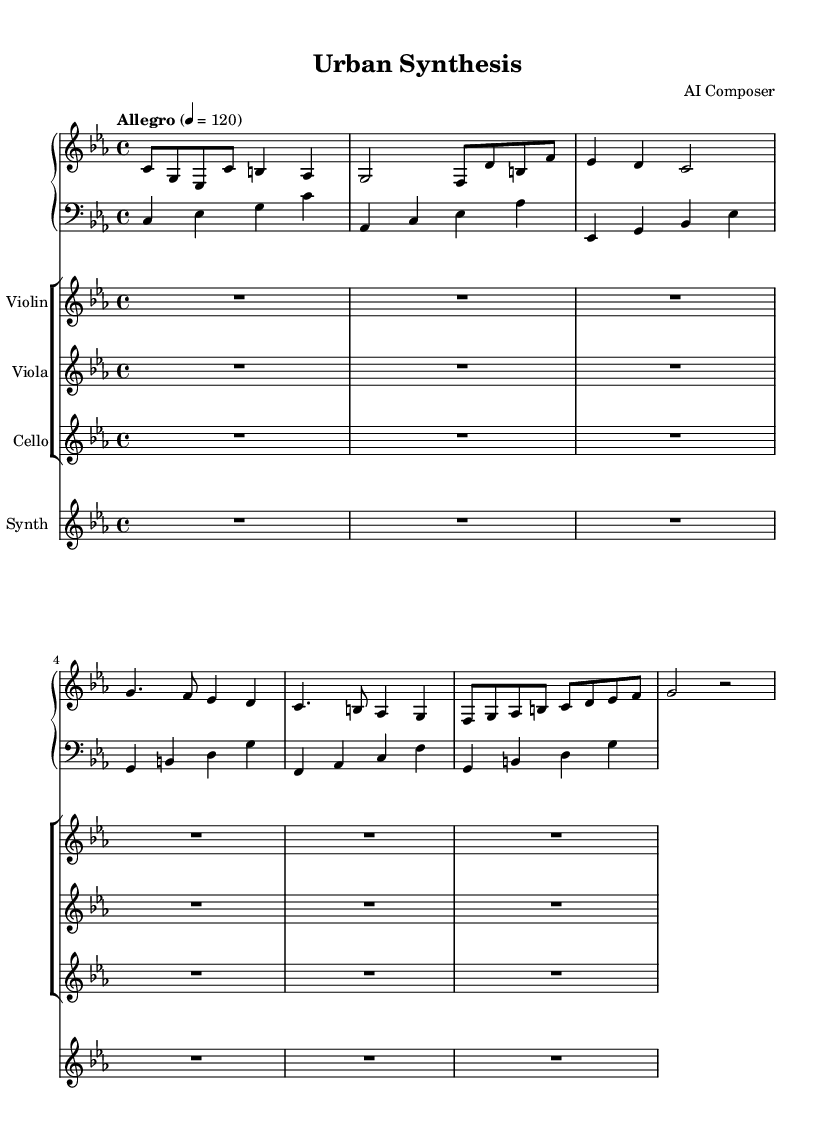What is the key signature of this music? The key signature is C minor, indicated by three flats in the key signature at the beginning of the staff.
Answer: C minor What is the time signature of this piece? The time signature is shown as 4/4 at the beginning of the score, meaning there are four beats per measure.
Answer: 4/4 What is the tempo marking for the piece? The tempo marking is provided as "Allegro," which typically indicates a fast and lively pace, and the numerical marking indicates a speed of 120 beats per minute.
Answer: Allegro How many measures are in the piano part? Counting the distinct measures in the piano staff, there are a total of 6 measures shown.
Answer: 6 What instruments are included in the score? The score lists the instruments as Piano, Violin, Viola, Cello, and Synthesizer, which are indicated by their respective staves in the score layout.
Answer: Piano, Violin, Viola, Cello, Synthesizer What is the name of the piece? The title of the piece is indicated at the top of the score: "Urban Synthesis."
Answer: Urban Synthesis How many clefs are used in the score? There are two different clefs present in the score: treble clef for the Piano, Violin, Viola, and Synthesizer; and bass clef for the lower part of the Piano.
Answer: 2 